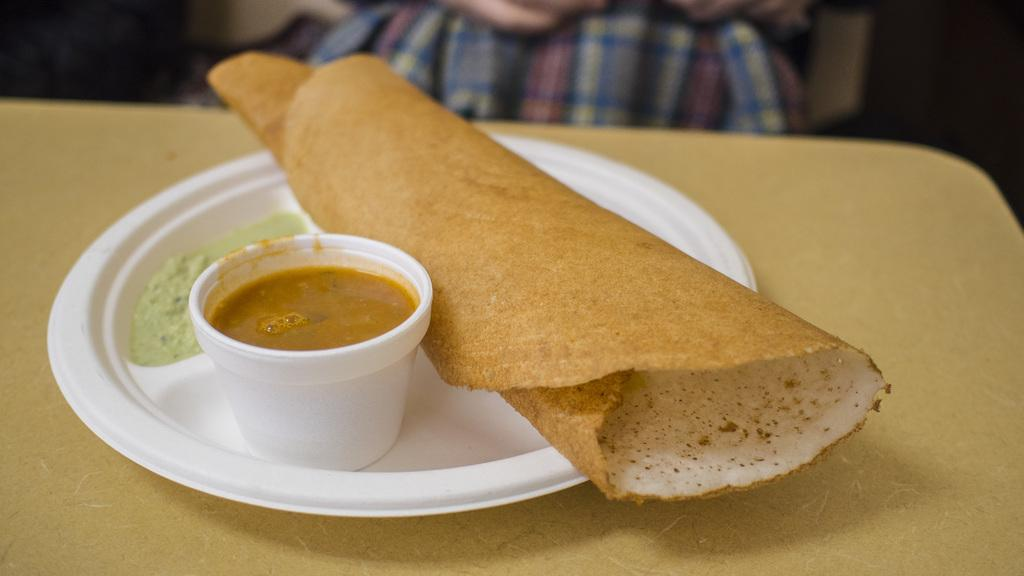What type of food is visible in the image? There is a dosa, chutney, and curry in the image. How are the food items arranged in the image? The food items are on a plate in the image. What is the surface beneath the plate in the image? There is a table at the bottom of the image. Can you describe the presence of any people in the image? There is a person in the background of the image. What type of can is visible in the image? There is no can present in the image. How many fairies are visible in the image? There are no fairies present in the image. 